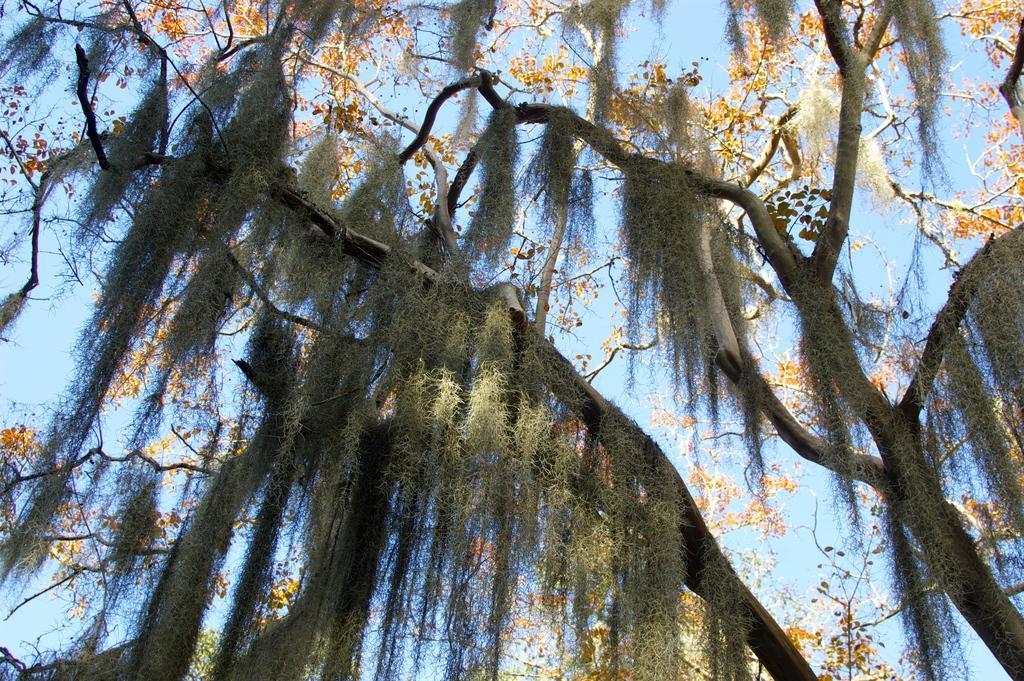Please provide a concise description of this image. In this image I can see there are leaves, flowers of the trees and the sky. 